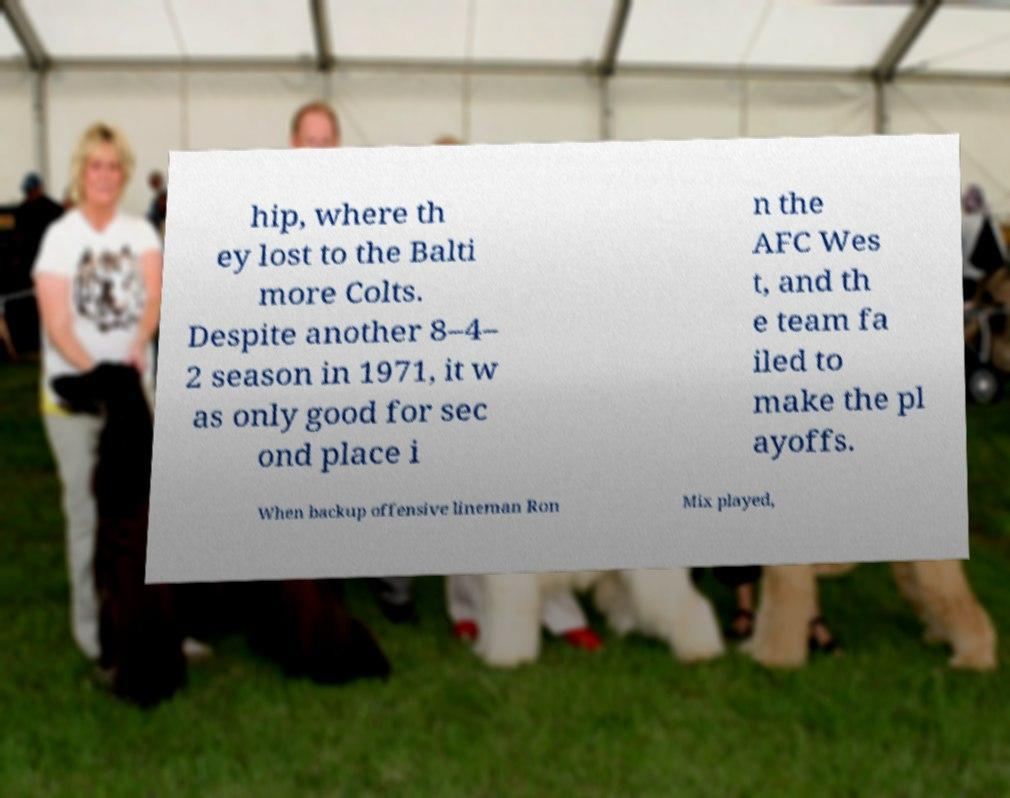Please read and relay the text visible in this image. What does it say? hip, where th ey lost to the Balti more Colts. Despite another 8–4– 2 season in 1971, it w as only good for sec ond place i n the AFC Wes t, and th e team fa iled to make the pl ayoffs. When backup offensive lineman Ron Mix played, 